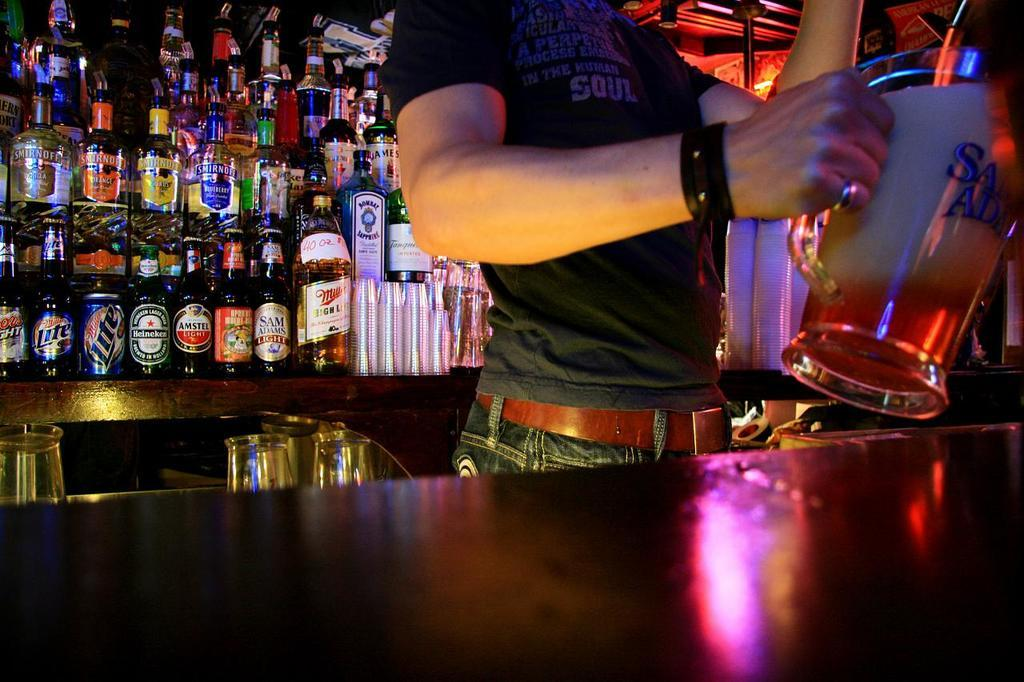What is the main structure in the image? There is a platform in the image. Who or what is on the platform? There is a person on the platform. What is the person holding? The person is holding a jug. What can be seen in the background of the image? There are bottles and other objects visible in the background of the image. What type of fiction is being advertised on the platform? There is no fiction or advertisement present in the image; it features a person holding a jug on a platform with bottles and other objects in the background. 